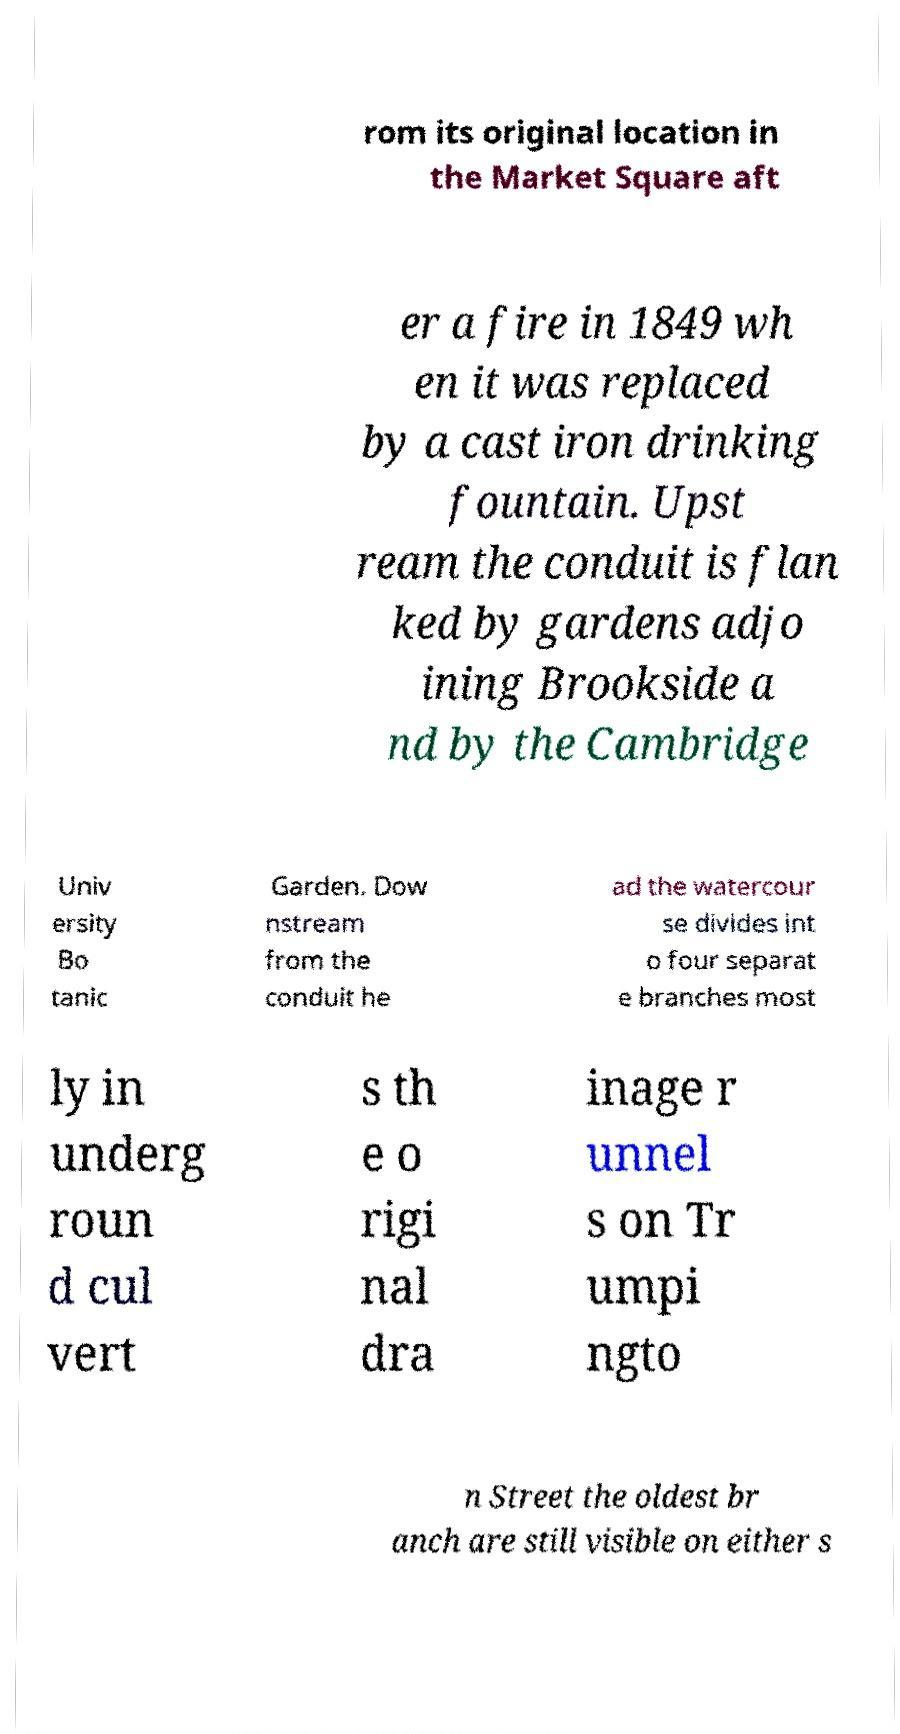Please identify and transcribe the text found in this image. rom its original location in the Market Square aft er a fire in 1849 wh en it was replaced by a cast iron drinking fountain. Upst ream the conduit is flan ked by gardens adjo ining Brookside a nd by the Cambridge Univ ersity Bo tanic Garden. Dow nstream from the conduit he ad the watercour se divides int o four separat e branches most ly in underg roun d cul vert s th e o rigi nal dra inage r unnel s on Tr umpi ngto n Street the oldest br anch are still visible on either s 